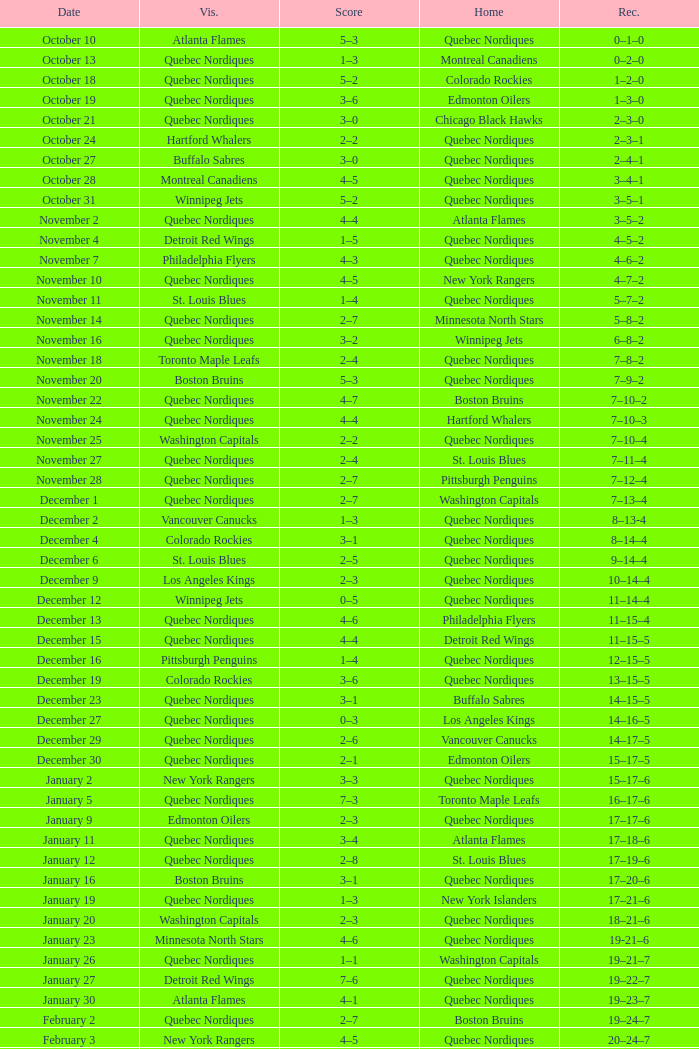Which Home has a Record of 16–17–6? Toronto Maple Leafs. 